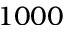Convert formula to latex. <formula><loc_0><loc_0><loc_500><loc_500>1 0 0 0</formula> 